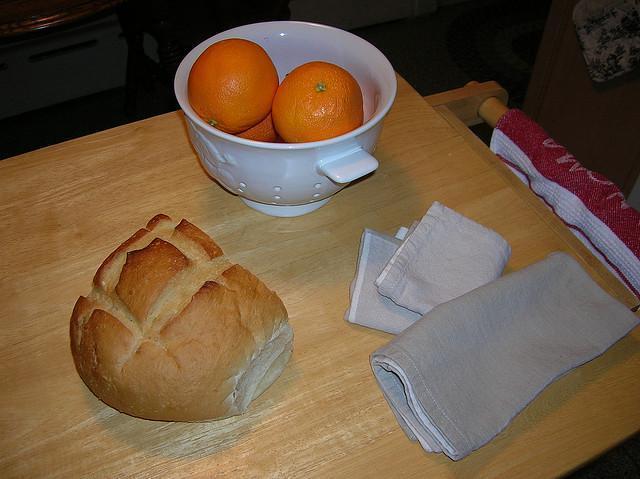How many oranges are there?
Give a very brief answer. 3. 